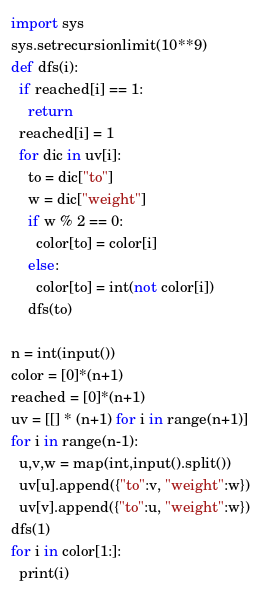Convert code to text. <code><loc_0><loc_0><loc_500><loc_500><_Python_>import sys
sys.setrecursionlimit(10**9)
def dfs(i):
  if reached[i] == 1:
    return
  reached[i] = 1
  for dic in uv[i]:
    to = dic["to"]
    w = dic["weight"]
    if w % 2 == 0:
      color[to] = color[i]
    else:
      color[to] = int(not color[i])
    dfs(to)

n = int(input())
color = [0]*(n+1)
reached = [0]*(n+1)
uv = [[] * (n+1) for i in range(n+1)]
for i in range(n-1):
  u,v,w = map(int,input().split())
  uv[u].append({"to":v, "weight":w})
  uv[v].append({"to":u, "weight":w})
dfs(1)
for i in color[1:]:
  print(i)</code> 